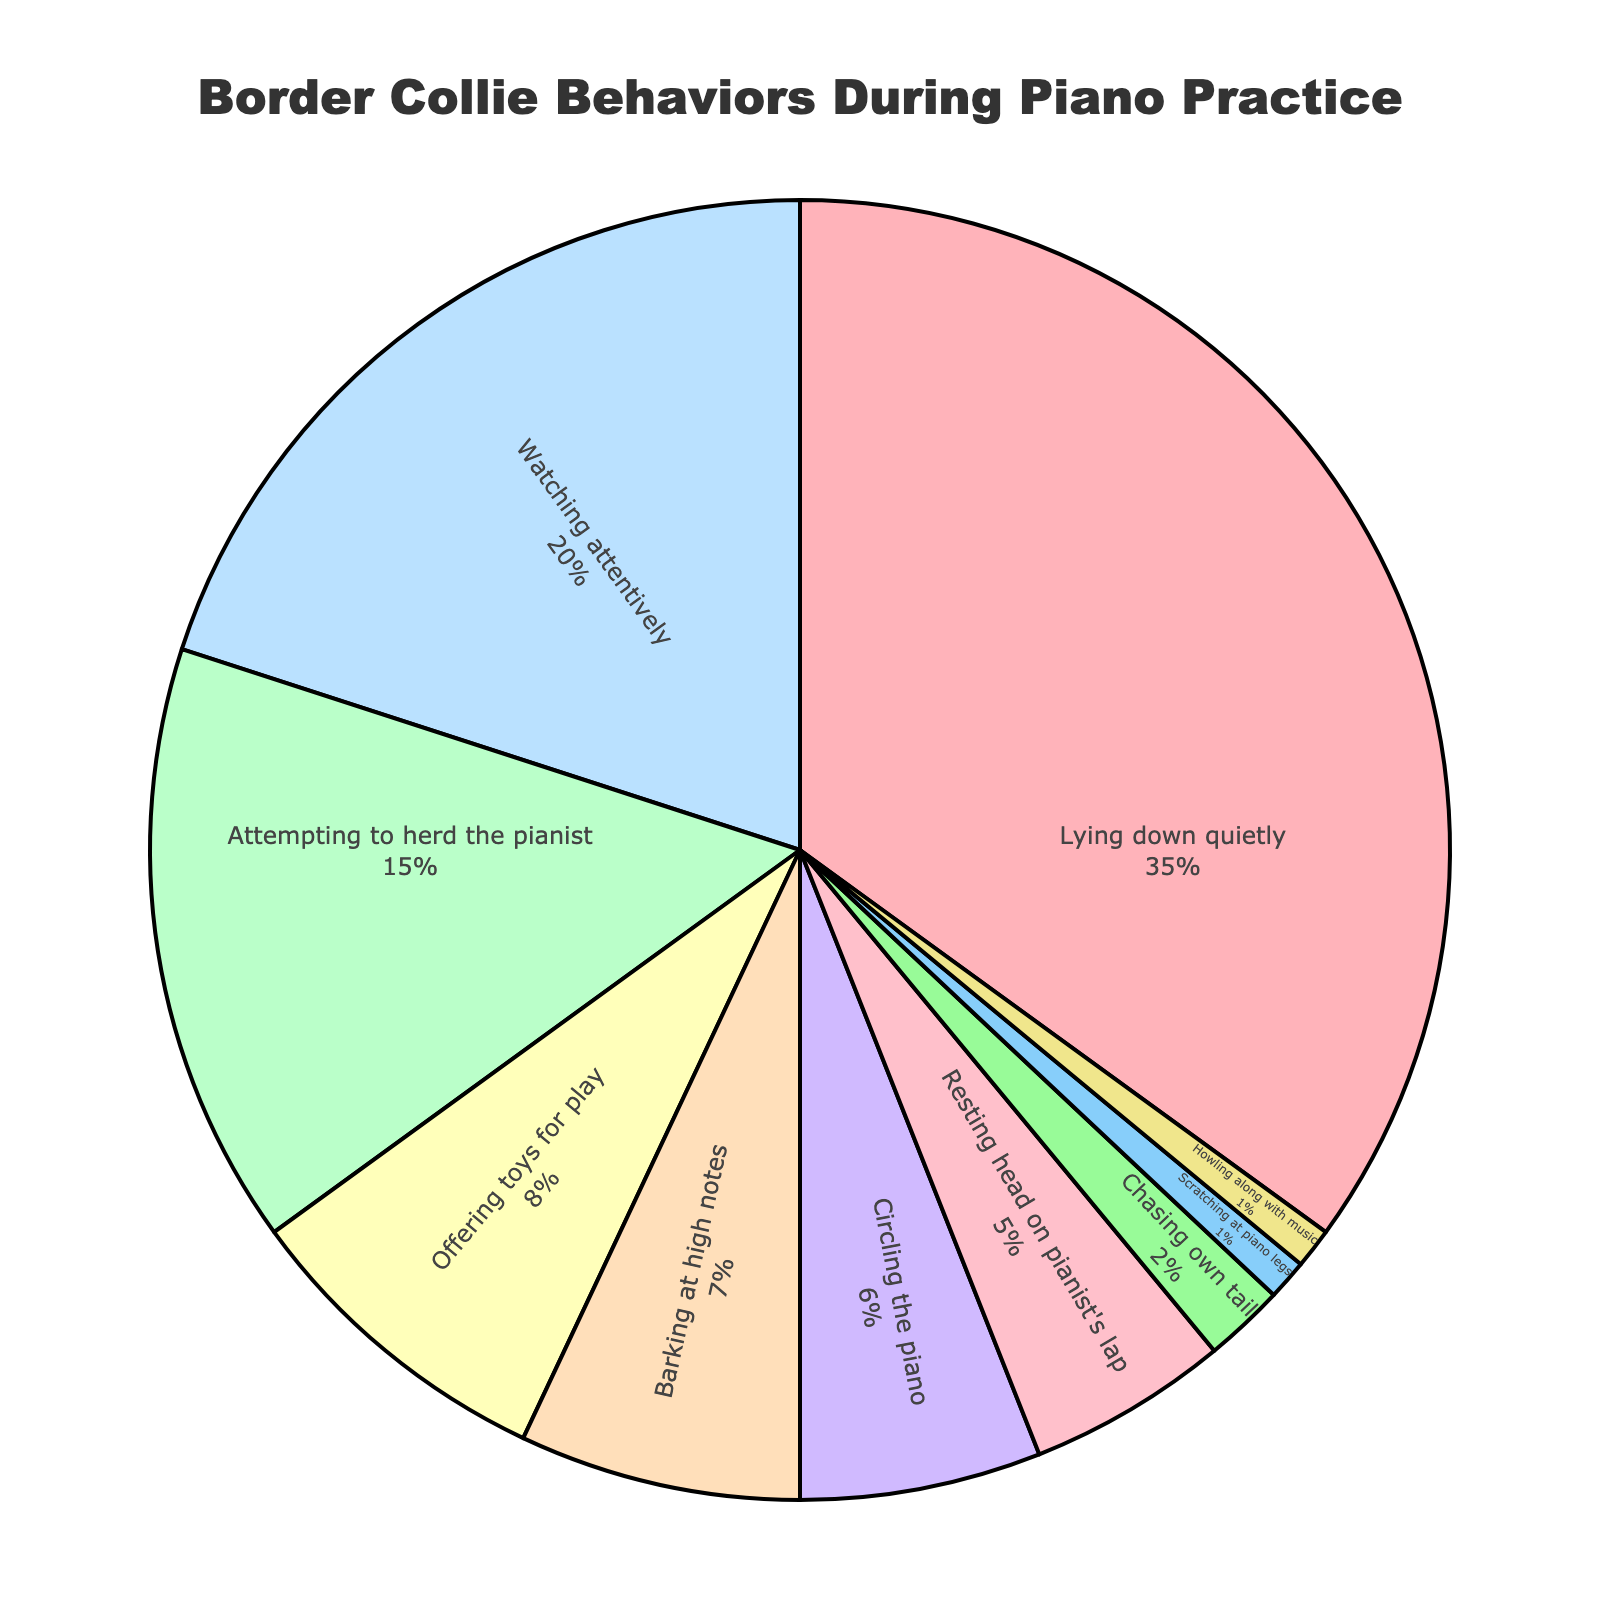Which behavior is the most common during the piano practice sessions? The segment labeled "Lying down quietly" has the largest percentage in the pie chart.
Answer: Lying down quietly What is the combined percentage of border collies watching attentively and resting their head on the pianist's lap? Adding the percentages for "Watching attentively" which is 20% and "Resting head on pianist's lap" which is 5%, the combined percentage is 20% + 5% = 25%.
Answer: 25% What behaviors constitute less than 5% of the total? The segments for "Chasing own tail" (2%), "Scratching at piano legs" (1%), and "Howling along with music" (1%) each constitute less than 5% of the total.
Answer: Chasing own tail, Scratching at piano legs, Howling along with music How much more common is the behavior "Lying down quietly" compared to "Attempting to herd the pianist"? The percentage for "Lying down quietly" is 35% and for "Attempting to herd the pianist" is 15%. Subtracting these values gives 35% - 15% = 20%.
Answer: 20% Which behavior is represented by the yellow segment in the pie chart? The yellow segment represents "Circling the piano".
Answer: Circling the piano If you combine the percentages of "Attempting to herd the pianist" and "Circling the piano", do they exceed the percentage of "Watching attentively"? Adding the percentages for "Attempting to herd the pianist" (15%) and "Circling the piano" (6%) results in 21%. Since 21% is greater than 20%, the combined percentage exceeds that of "Watching attentively".
Answer: Yes Which behavior has the smallest percentage and how much is it? The segment for "Scratching at piano legs" and "Howling along with music" both have the smallest percentage at 1% each.
Answer: Scratching at piano legs, Howling along with music What is the total percentage of behaviors other than "Lying down quietly"? Subtracting the percentage of "Lying down quietly" from 100% gives 100% - 35% = 65%.
Answer: 65% 